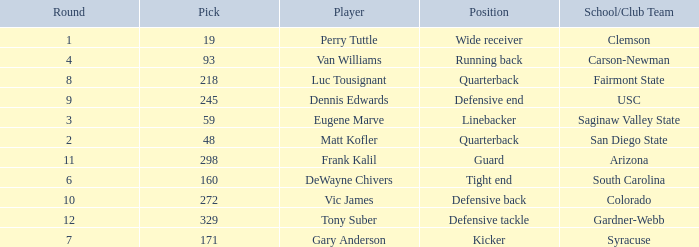Who plays linebacker? Eugene Marve. Give me the full table as a dictionary. {'header': ['Round', 'Pick', 'Player', 'Position', 'School/Club Team'], 'rows': [['1', '19', 'Perry Tuttle', 'Wide receiver', 'Clemson'], ['4', '93', 'Van Williams', 'Running back', 'Carson-Newman'], ['8', '218', 'Luc Tousignant', 'Quarterback', 'Fairmont State'], ['9', '245', 'Dennis Edwards', 'Defensive end', 'USC'], ['3', '59', 'Eugene Marve', 'Linebacker', 'Saginaw Valley State'], ['2', '48', 'Matt Kofler', 'Quarterback', 'San Diego State'], ['11', '298', 'Frank Kalil', 'Guard', 'Arizona'], ['6', '160', 'DeWayne Chivers', 'Tight end', 'South Carolina'], ['10', '272', 'Vic James', 'Defensive back', 'Colorado'], ['12', '329', 'Tony Suber', 'Defensive tackle', 'Gardner-Webb'], ['7', '171', 'Gary Anderson', 'Kicker', 'Syracuse']]} 